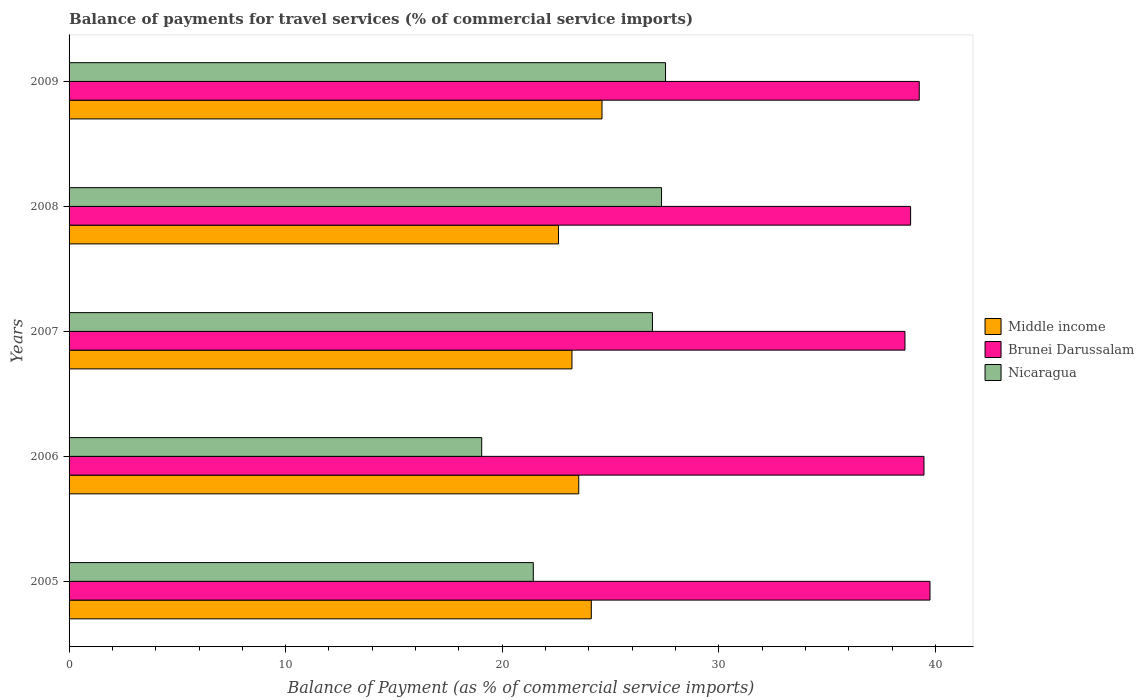How many different coloured bars are there?
Provide a succinct answer. 3. Are the number of bars per tick equal to the number of legend labels?
Offer a very short reply. Yes. Are the number of bars on each tick of the Y-axis equal?
Ensure brevity in your answer.  Yes. How many bars are there on the 1st tick from the top?
Your response must be concise. 3. What is the balance of payments for travel services in Middle income in 2006?
Make the answer very short. 23.53. Across all years, what is the maximum balance of payments for travel services in Middle income?
Your response must be concise. 24.61. Across all years, what is the minimum balance of payments for travel services in Middle income?
Give a very brief answer. 22.6. What is the total balance of payments for travel services in Brunei Darussalam in the graph?
Your answer should be compact. 195.93. What is the difference between the balance of payments for travel services in Brunei Darussalam in 2005 and that in 2006?
Provide a succinct answer. 0.28. What is the difference between the balance of payments for travel services in Brunei Darussalam in 2005 and the balance of payments for travel services in Nicaragua in 2009?
Provide a succinct answer. 12.21. What is the average balance of payments for travel services in Middle income per year?
Ensure brevity in your answer.  23.61. In the year 2006, what is the difference between the balance of payments for travel services in Brunei Darussalam and balance of payments for travel services in Middle income?
Give a very brief answer. 15.94. What is the ratio of the balance of payments for travel services in Brunei Darussalam in 2008 to that in 2009?
Ensure brevity in your answer.  0.99. What is the difference between the highest and the second highest balance of payments for travel services in Nicaragua?
Keep it short and to the point. 0.19. What is the difference between the highest and the lowest balance of payments for travel services in Brunei Darussalam?
Offer a very short reply. 1.16. Is the sum of the balance of payments for travel services in Middle income in 2006 and 2009 greater than the maximum balance of payments for travel services in Nicaragua across all years?
Keep it short and to the point. Yes. What does the 2nd bar from the top in 2005 represents?
Ensure brevity in your answer.  Brunei Darussalam. What does the 1st bar from the bottom in 2007 represents?
Offer a very short reply. Middle income. Does the graph contain any zero values?
Offer a very short reply. No. Does the graph contain grids?
Offer a very short reply. No. What is the title of the graph?
Offer a very short reply. Balance of payments for travel services (% of commercial service imports). What is the label or title of the X-axis?
Provide a succinct answer. Balance of Payment (as % of commercial service imports). What is the Balance of Payment (as % of commercial service imports) of Middle income in 2005?
Ensure brevity in your answer.  24.11. What is the Balance of Payment (as % of commercial service imports) of Brunei Darussalam in 2005?
Make the answer very short. 39.75. What is the Balance of Payment (as % of commercial service imports) in Nicaragua in 2005?
Ensure brevity in your answer.  21.44. What is the Balance of Payment (as % of commercial service imports) in Middle income in 2006?
Make the answer very short. 23.53. What is the Balance of Payment (as % of commercial service imports) of Brunei Darussalam in 2006?
Your answer should be very brief. 39.47. What is the Balance of Payment (as % of commercial service imports) of Nicaragua in 2006?
Your response must be concise. 19.05. What is the Balance of Payment (as % of commercial service imports) of Middle income in 2007?
Offer a terse response. 23.22. What is the Balance of Payment (as % of commercial service imports) in Brunei Darussalam in 2007?
Ensure brevity in your answer.  38.59. What is the Balance of Payment (as % of commercial service imports) of Nicaragua in 2007?
Make the answer very short. 26.94. What is the Balance of Payment (as % of commercial service imports) of Middle income in 2008?
Give a very brief answer. 22.6. What is the Balance of Payment (as % of commercial service imports) of Brunei Darussalam in 2008?
Your response must be concise. 38.86. What is the Balance of Payment (as % of commercial service imports) of Nicaragua in 2008?
Offer a terse response. 27.36. What is the Balance of Payment (as % of commercial service imports) in Middle income in 2009?
Make the answer very short. 24.61. What is the Balance of Payment (as % of commercial service imports) of Brunei Darussalam in 2009?
Keep it short and to the point. 39.25. What is the Balance of Payment (as % of commercial service imports) of Nicaragua in 2009?
Give a very brief answer. 27.54. Across all years, what is the maximum Balance of Payment (as % of commercial service imports) in Middle income?
Offer a terse response. 24.61. Across all years, what is the maximum Balance of Payment (as % of commercial service imports) in Brunei Darussalam?
Give a very brief answer. 39.75. Across all years, what is the maximum Balance of Payment (as % of commercial service imports) in Nicaragua?
Keep it short and to the point. 27.54. Across all years, what is the minimum Balance of Payment (as % of commercial service imports) of Middle income?
Make the answer very short. 22.6. Across all years, what is the minimum Balance of Payment (as % of commercial service imports) in Brunei Darussalam?
Ensure brevity in your answer.  38.59. Across all years, what is the minimum Balance of Payment (as % of commercial service imports) in Nicaragua?
Keep it short and to the point. 19.05. What is the total Balance of Payment (as % of commercial service imports) of Middle income in the graph?
Provide a succinct answer. 118.07. What is the total Balance of Payment (as % of commercial service imports) in Brunei Darussalam in the graph?
Your answer should be very brief. 195.93. What is the total Balance of Payment (as % of commercial service imports) of Nicaragua in the graph?
Provide a short and direct response. 122.32. What is the difference between the Balance of Payment (as % of commercial service imports) of Middle income in 2005 and that in 2006?
Give a very brief answer. 0.58. What is the difference between the Balance of Payment (as % of commercial service imports) of Brunei Darussalam in 2005 and that in 2006?
Give a very brief answer. 0.28. What is the difference between the Balance of Payment (as % of commercial service imports) of Nicaragua in 2005 and that in 2006?
Your response must be concise. 2.38. What is the difference between the Balance of Payment (as % of commercial service imports) in Middle income in 2005 and that in 2007?
Offer a terse response. 0.89. What is the difference between the Balance of Payment (as % of commercial service imports) of Brunei Darussalam in 2005 and that in 2007?
Make the answer very short. 1.16. What is the difference between the Balance of Payment (as % of commercial service imports) of Nicaragua in 2005 and that in 2007?
Ensure brevity in your answer.  -5.5. What is the difference between the Balance of Payment (as % of commercial service imports) of Middle income in 2005 and that in 2008?
Your answer should be very brief. 1.52. What is the difference between the Balance of Payment (as % of commercial service imports) of Brunei Darussalam in 2005 and that in 2008?
Your response must be concise. 0.9. What is the difference between the Balance of Payment (as % of commercial service imports) of Nicaragua in 2005 and that in 2008?
Offer a terse response. -5.92. What is the difference between the Balance of Payment (as % of commercial service imports) of Middle income in 2005 and that in 2009?
Ensure brevity in your answer.  -0.49. What is the difference between the Balance of Payment (as % of commercial service imports) of Brunei Darussalam in 2005 and that in 2009?
Provide a short and direct response. 0.5. What is the difference between the Balance of Payment (as % of commercial service imports) of Nicaragua in 2005 and that in 2009?
Offer a terse response. -6.11. What is the difference between the Balance of Payment (as % of commercial service imports) in Middle income in 2006 and that in 2007?
Ensure brevity in your answer.  0.31. What is the difference between the Balance of Payment (as % of commercial service imports) in Brunei Darussalam in 2006 and that in 2007?
Ensure brevity in your answer.  0.88. What is the difference between the Balance of Payment (as % of commercial service imports) in Nicaragua in 2006 and that in 2007?
Make the answer very short. -7.88. What is the difference between the Balance of Payment (as % of commercial service imports) in Middle income in 2006 and that in 2008?
Offer a very short reply. 0.94. What is the difference between the Balance of Payment (as % of commercial service imports) of Brunei Darussalam in 2006 and that in 2008?
Offer a terse response. 0.62. What is the difference between the Balance of Payment (as % of commercial service imports) of Nicaragua in 2006 and that in 2008?
Make the answer very short. -8.3. What is the difference between the Balance of Payment (as % of commercial service imports) in Middle income in 2006 and that in 2009?
Provide a succinct answer. -1.07. What is the difference between the Balance of Payment (as % of commercial service imports) of Brunei Darussalam in 2006 and that in 2009?
Ensure brevity in your answer.  0.22. What is the difference between the Balance of Payment (as % of commercial service imports) in Nicaragua in 2006 and that in 2009?
Your response must be concise. -8.49. What is the difference between the Balance of Payment (as % of commercial service imports) in Middle income in 2007 and that in 2008?
Make the answer very short. 0.62. What is the difference between the Balance of Payment (as % of commercial service imports) of Brunei Darussalam in 2007 and that in 2008?
Your answer should be compact. -0.26. What is the difference between the Balance of Payment (as % of commercial service imports) in Nicaragua in 2007 and that in 2008?
Provide a succinct answer. -0.42. What is the difference between the Balance of Payment (as % of commercial service imports) in Middle income in 2007 and that in 2009?
Keep it short and to the point. -1.39. What is the difference between the Balance of Payment (as % of commercial service imports) in Brunei Darussalam in 2007 and that in 2009?
Provide a succinct answer. -0.66. What is the difference between the Balance of Payment (as % of commercial service imports) in Nicaragua in 2007 and that in 2009?
Offer a very short reply. -0.61. What is the difference between the Balance of Payment (as % of commercial service imports) in Middle income in 2008 and that in 2009?
Keep it short and to the point. -2.01. What is the difference between the Balance of Payment (as % of commercial service imports) of Brunei Darussalam in 2008 and that in 2009?
Ensure brevity in your answer.  -0.4. What is the difference between the Balance of Payment (as % of commercial service imports) of Nicaragua in 2008 and that in 2009?
Your answer should be very brief. -0.19. What is the difference between the Balance of Payment (as % of commercial service imports) in Middle income in 2005 and the Balance of Payment (as % of commercial service imports) in Brunei Darussalam in 2006?
Provide a succinct answer. -15.36. What is the difference between the Balance of Payment (as % of commercial service imports) in Middle income in 2005 and the Balance of Payment (as % of commercial service imports) in Nicaragua in 2006?
Make the answer very short. 5.06. What is the difference between the Balance of Payment (as % of commercial service imports) in Brunei Darussalam in 2005 and the Balance of Payment (as % of commercial service imports) in Nicaragua in 2006?
Offer a terse response. 20.7. What is the difference between the Balance of Payment (as % of commercial service imports) in Middle income in 2005 and the Balance of Payment (as % of commercial service imports) in Brunei Darussalam in 2007?
Ensure brevity in your answer.  -14.48. What is the difference between the Balance of Payment (as % of commercial service imports) in Middle income in 2005 and the Balance of Payment (as % of commercial service imports) in Nicaragua in 2007?
Ensure brevity in your answer.  -2.82. What is the difference between the Balance of Payment (as % of commercial service imports) of Brunei Darussalam in 2005 and the Balance of Payment (as % of commercial service imports) of Nicaragua in 2007?
Give a very brief answer. 12.82. What is the difference between the Balance of Payment (as % of commercial service imports) of Middle income in 2005 and the Balance of Payment (as % of commercial service imports) of Brunei Darussalam in 2008?
Make the answer very short. -14.74. What is the difference between the Balance of Payment (as % of commercial service imports) in Middle income in 2005 and the Balance of Payment (as % of commercial service imports) in Nicaragua in 2008?
Provide a short and direct response. -3.24. What is the difference between the Balance of Payment (as % of commercial service imports) in Brunei Darussalam in 2005 and the Balance of Payment (as % of commercial service imports) in Nicaragua in 2008?
Make the answer very short. 12.4. What is the difference between the Balance of Payment (as % of commercial service imports) in Middle income in 2005 and the Balance of Payment (as % of commercial service imports) in Brunei Darussalam in 2009?
Make the answer very short. -15.14. What is the difference between the Balance of Payment (as % of commercial service imports) of Middle income in 2005 and the Balance of Payment (as % of commercial service imports) of Nicaragua in 2009?
Your answer should be very brief. -3.43. What is the difference between the Balance of Payment (as % of commercial service imports) of Brunei Darussalam in 2005 and the Balance of Payment (as % of commercial service imports) of Nicaragua in 2009?
Give a very brief answer. 12.21. What is the difference between the Balance of Payment (as % of commercial service imports) in Middle income in 2006 and the Balance of Payment (as % of commercial service imports) in Brunei Darussalam in 2007?
Offer a terse response. -15.06. What is the difference between the Balance of Payment (as % of commercial service imports) of Middle income in 2006 and the Balance of Payment (as % of commercial service imports) of Nicaragua in 2007?
Keep it short and to the point. -3.4. What is the difference between the Balance of Payment (as % of commercial service imports) in Brunei Darussalam in 2006 and the Balance of Payment (as % of commercial service imports) in Nicaragua in 2007?
Your answer should be compact. 12.54. What is the difference between the Balance of Payment (as % of commercial service imports) in Middle income in 2006 and the Balance of Payment (as % of commercial service imports) in Brunei Darussalam in 2008?
Your answer should be very brief. -15.32. What is the difference between the Balance of Payment (as % of commercial service imports) in Middle income in 2006 and the Balance of Payment (as % of commercial service imports) in Nicaragua in 2008?
Ensure brevity in your answer.  -3.82. What is the difference between the Balance of Payment (as % of commercial service imports) in Brunei Darussalam in 2006 and the Balance of Payment (as % of commercial service imports) in Nicaragua in 2008?
Offer a very short reply. 12.12. What is the difference between the Balance of Payment (as % of commercial service imports) of Middle income in 2006 and the Balance of Payment (as % of commercial service imports) of Brunei Darussalam in 2009?
Make the answer very short. -15.72. What is the difference between the Balance of Payment (as % of commercial service imports) in Middle income in 2006 and the Balance of Payment (as % of commercial service imports) in Nicaragua in 2009?
Provide a short and direct response. -4.01. What is the difference between the Balance of Payment (as % of commercial service imports) of Brunei Darussalam in 2006 and the Balance of Payment (as % of commercial service imports) of Nicaragua in 2009?
Give a very brief answer. 11.93. What is the difference between the Balance of Payment (as % of commercial service imports) in Middle income in 2007 and the Balance of Payment (as % of commercial service imports) in Brunei Darussalam in 2008?
Provide a short and direct response. -15.64. What is the difference between the Balance of Payment (as % of commercial service imports) in Middle income in 2007 and the Balance of Payment (as % of commercial service imports) in Nicaragua in 2008?
Your answer should be very brief. -4.14. What is the difference between the Balance of Payment (as % of commercial service imports) in Brunei Darussalam in 2007 and the Balance of Payment (as % of commercial service imports) in Nicaragua in 2008?
Provide a succinct answer. 11.24. What is the difference between the Balance of Payment (as % of commercial service imports) in Middle income in 2007 and the Balance of Payment (as % of commercial service imports) in Brunei Darussalam in 2009?
Your answer should be very brief. -16.04. What is the difference between the Balance of Payment (as % of commercial service imports) in Middle income in 2007 and the Balance of Payment (as % of commercial service imports) in Nicaragua in 2009?
Keep it short and to the point. -4.32. What is the difference between the Balance of Payment (as % of commercial service imports) of Brunei Darussalam in 2007 and the Balance of Payment (as % of commercial service imports) of Nicaragua in 2009?
Your answer should be compact. 11.05. What is the difference between the Balance of Payment (as % of commercial service imports) of Middle income in 2008 and the Balance of Payment (as % of commercial service imports) of Brunei Darussalam in 2009?
Provide a short and direct response. -16.66. What is the difference between the Balance of Payment (as % of commercial service imports) in Middle income in 2008 and the Balance of Payment (as % of commercial service imports) in Nicaragua in 2009?
Give a very brief answer. -4.94. What is the difference between the Balance of Payment (as % of commercial service imports) in Brunei Darussalam in 2008 and the Balance of Payment (as % of commercial service imports) in Nicaragua in 2009?
Provide a short and direct response. 11.31. What is the average Balance of Payment (as % of commercial service imports) of Middle income per year?
Offer a very short reply. 23.61. What is the average Balance of Payment (as % of commercial service imports) in Brunei Darussalam per year?
Offer a very short reply. 39.19. What is the average Balance of Payment (as % of commercial service imports) of Nicaragua per year?
Provide a succinct answer. 24.46. In the year 2005, what is the difference between the Balance of Payment (as % of commercial service imports) in Middle income and Balance of Payment (as % of commercial service imports) in Brunei Darussalam?
Give a very brief answer. -15.64. In the year 2005, what is the difference between the Balance of Payment (as % of commercial service imports) in Middle income and Balance of Payment (as % of commercial service imports) in Nicaragua?
Provide a short and direct response. 2.68. In the year 2005, what is the difference between the Balance of Payment (as % of commercial service imports) in Brunei Darussalam and Balance of Payment (as % of commercial service imports) in Nicaragua?
Your response must be concise. 18.32. In the year 2006, what is the difference between the Balance of Payment (as % of commercial service imports) in Middle income and Balance of Payment (as % of commercial service imports) in Brunei Darussalam?
Give a very brief answer. -15.94. In the year 2006, what is the difference between the Balance of Payment (as % of commercial service imports) of Middle income and Balance of Payment (as % of commercial service imports) of Nicaragua?
Make the answer very short. 4.48. In the year 2006, what is the difference between the Balance of Payment (as % of commercial service imports) of Brunei Darussalam and Balance of Payment (as % of commercial service imports) of Nicaragua?
Offer a very short reply. 20.42. In the year 2007, what is the difference between the Balance of Payment (as % of commercial service imports) in Middle income and Balance of Payment (as % of commercial service imports) in Brunei Darussalam?
Keep it short and to the point. -15.38. In the year 2007, what is the difference between the Balance of Payment (as % of commercial service imports) in Middle income and Balance of Payment (as % of commercial service imports) in Nicaragua?
Offer a very short reply. -3.72. In the year 2007, what is the difference between the Balance of Payment (as % of commercial service imports) of Brunei Darussalam and Balance of Payment (as % of commercial service imports) of Nicaragua?
Offer a terse response. 11.66. In the year 2008, what is the difference between the Balance of Payment (as % of commercial service imports) in Middle income and Balance of Payment (as % of commercial service imports) in Brunei Darussalam?
Offer a very short reply. -16.26. In the year 2008, what is the difference between the Balance of Payment (as % of commercial service imports) in Middle income and Balance of Payment (as % of commercial service imports) in Nicaragua?
Your answer should be very brief. -4.76. In the year 2008, what is the difference between the Balance of Payment (as % of commercial service imports) in Brunei Darussalam and Balance of Payment (as % of commercial service imports) in Nicaragua?
Your answer should be very brief. 11.5. In the year 2009, what is the difference between the Balance of Payment (as % of commercial service imports) in Middle income and Balance of Payment (as % of commercial service imports) in Brunei Darussalam?
Provide a succinct answer. -14.65. In the year 2009, what is the difference between the Balance of Payment (as % of commercial service imports) of Middle income and Balance of Payment (as % of commercial service imports) of Nicaragua?
Ensure brevity in your answer.  -2.93. In the year 2009, what is the difference between the Balance of Payment (as % of commercial service imports) of Brunei Darussalam and Balance of Payment (as % of commercial service imports) of Nicaragua?
Your response must be concise. 11.71. What is the ratio of the Balance of Payment (as % of commercial service imports) of Middle income in 2005 to that in 2006?
Provide a short and direct response. 1.02. What is the ratio of the Balance of Payment (as % of commercial service imports) of Brunei Darussalam in 2005 to that in 2006?
Offer a terse response. 1.01. What is the ratio of the Balance of Payment (as % of commercial service imports) of Nicaragua in 2005 to that in 2006?
Your response must be concise. 1.12. What is the ratio of the Balance of Payment (as % of commercial service imports) of Brunei Darussalam in 2005 to that in 2007?
Keep it short and to the point. 1.03. What is the ratio of the Balance of Payment (as % of commercial service imports) in Nicaragua in 2005 to that in 2007?
Make the answer very short. 0.8. What is the ratio of the Balance of Payment (as % of commercial service imports) of Middle income in 2005 to that in 2008?
Make the answer very short. 1.07. What is the ratio of the Balance of Payment (as % of commercial service imports) in Nicaragua in 2005 to that in 2008?
Provide a succinct answer. 0.78. What is the ratio of the Balance of Payment (as % of commercial service imports) of Brunei Darussalam in 2005 to that in 2009?
Offer a very short reply. 1.01. What is the ratio of the Balance of Payment (as % of commercial service imports) in Nicaragua in 2005 to that in 2009?
Ensure brevity in your answer.  0.78. What is the ratio of the Balance of Payment (as % of commercial service imports) of Middle income in 2006 to that in 2007?
Keep it short and to the point. 1.01. What is the ratio of the Balance of Payment (as % of commercial service imports) in Brunei Darussalam in 2006 to that in 2007?
Offer a very short reply. 1.02. What is the ratio of the Balance of Payment (as % of commercial service imports) of Nicaragua in 2006 to that in 2007?
Your response must be concise. 0.71. What is the ratio of the Balance of Payment (as % of commercial service imports) of Middle income in 2006 to that in 2008?
Ensure brevity in your answer.  1.04. What is the ratio of the Balance of Payment (as % of commercial service imports) in Brunei Darussalam in 2006 to that in 2008?
Give a very brief answer. 1.02. What is the ratio of the Balance of Payment (as % of commercial service imports) in Nicaragua in 2006 to that in 2008?
Ensure brevity in your answer.  0.7. What is the ratio of the Balance of Payment (as % of commercial service imports) of Middle income in 2006 to that in 2009?
Offer a terse response. 0.96. What is the ratio of the Balance of Payment (as % of commercial service imports) of Brunei Darussalam in 2006 to that in 2009?
Keep it short and to the point. 1.01. What is the ratio of the Balance of Payment (as % of commercial service imports) in Nicaragua in 2006 to that in 2009?
Make the answer very short. 0.69. What is the ratio of the Balance of Payment (as % of commercial service imports) of Middle income in 2007 to that in 2008?
Ensure brevity in your answer.  1.03. What is the ratio of the Balance of Payment (as % of commercial service imports) of Nicaragua in 2007 to that in 2008?
Your response must be concise. 0.98. What is the ratio of the Balance of Payment (as % of commercial service imports) of Middle income in 2007 to that in 2009?
Make the answer very short. 0.94. What is the ratio of the Balance of Payment (as % of commercial service imports) in Brunei Darussalam in 2007 to that in 2009?
Offer a terse response. 0.98. What is the ratio of the Balance of Payment (as % of commercial service imports) of Middle income in 2008 to that in 2009?
Your answer should be compact. 0.92. What is the difference between the highest and the second highest Balance of Payment (as % of commercial service imports) in Middle income?
Your answer should be compact. 0.49. What is the difference between the highest and the second highest Balance of Payment (as % of commercial service imports) of Brunei Darussalam?
Your answer should be very brief. 0.28. What is the difference between the highest and the second highest Balance of Payment (as % of commercial service imports) in Nicaragua?
Make the answer very short. 0.19. What is the difference between the highest and the lowest Balance of Payment (as % of commercial service imports) of Middle income?
Ensure brevity in your answer.  2.01. What is the difference between the highest and the lowest Balance of Payment (as % of commercial service imports) of Brunei Darussalam?
Make the answer very short. 1.16. What is the difference between the highest and the lowest Balance of Payment (as % of commercial service imports) of Nicaragua?
Provide a short and direct response. 8.49. 